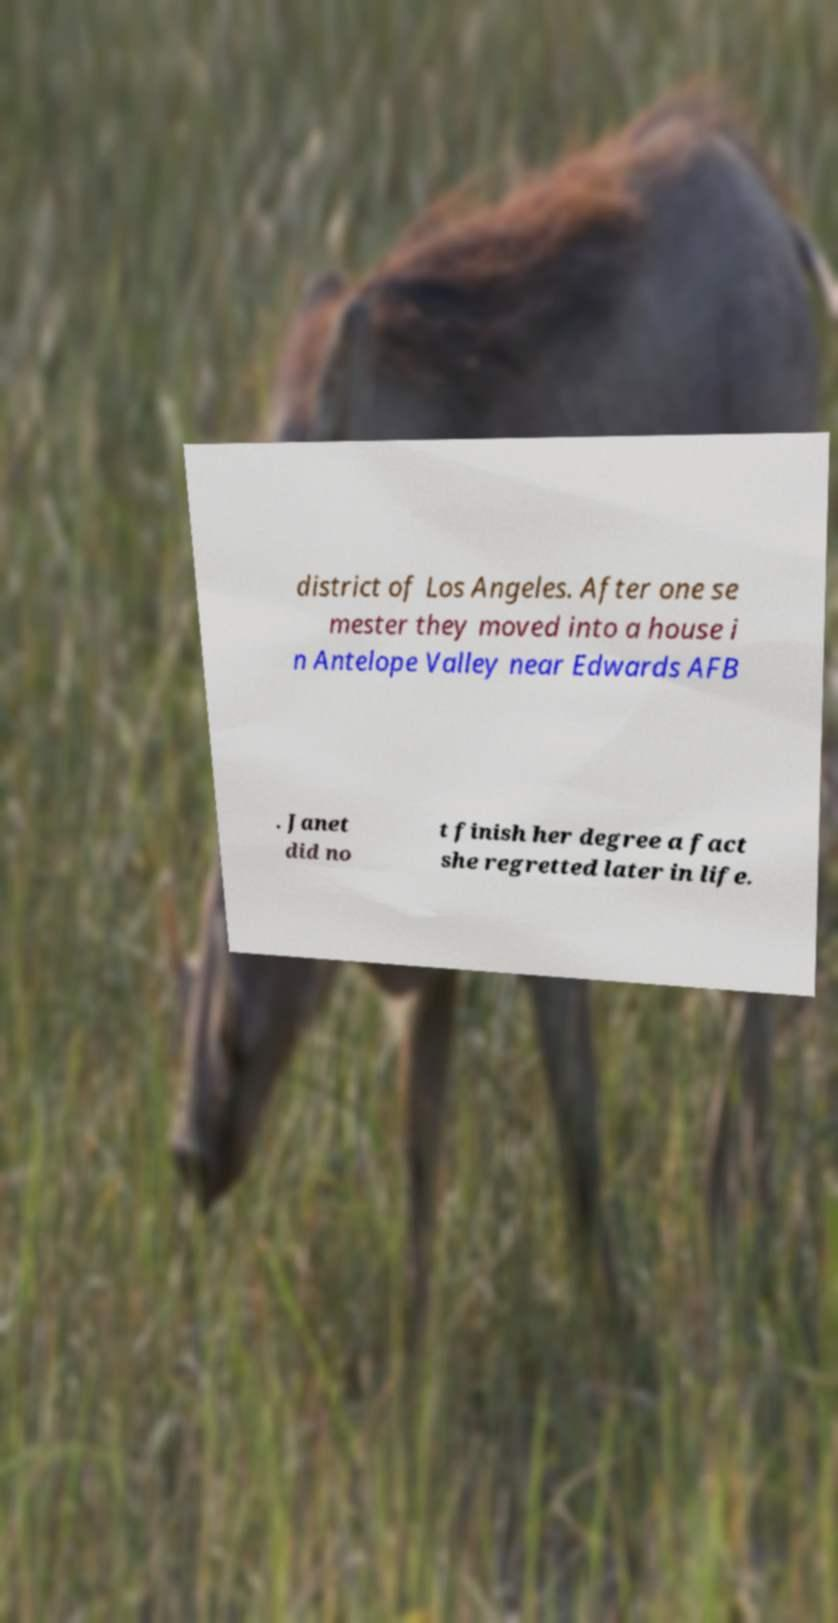There's text embedded in this image that I need extracted. Can you transcribe it verbatim? district of Los Angeles. After one se mester they moved into a house i n Antelope Valley near Edwards AFB . Janet did no t finish her degree a fact she regretted later in life. 